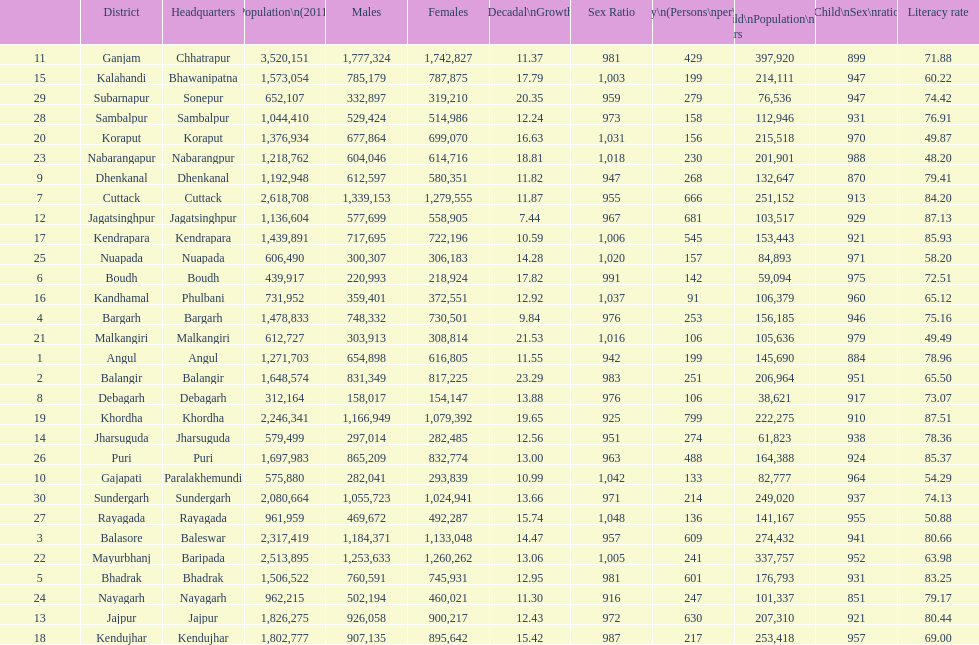How many females live in cuttack? 1,279,555. 